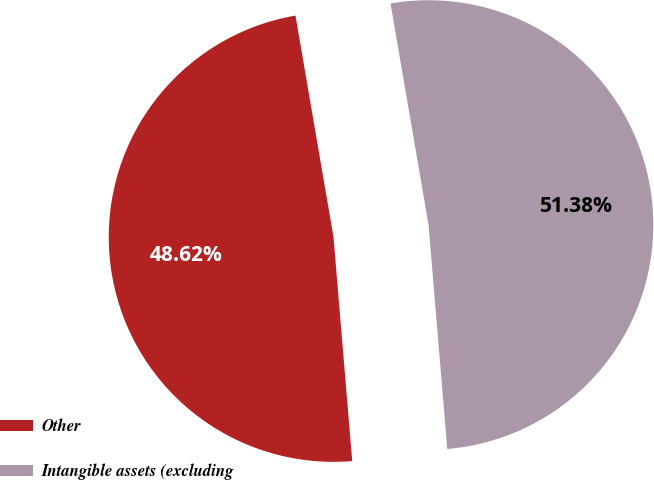Convert chart. <chart><loc_0><loc_0><loc_500><loc_500><pie_chart><fcel>Other<fcel>Intangible assets (excluding<nl><fcel>48.62%<fcel>51.38%<nl></chart> 